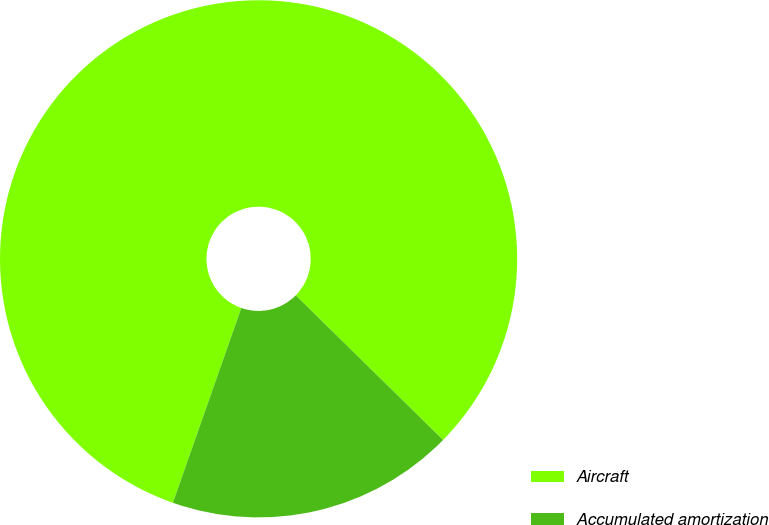<chart> <loc_0><loc_0><loc_500><loc_500><pie_chart><fcel>Aircraft<fcel>Accumulated amortization<nl><fcel>81.98%<fcel>18.02%<nl></chart> 